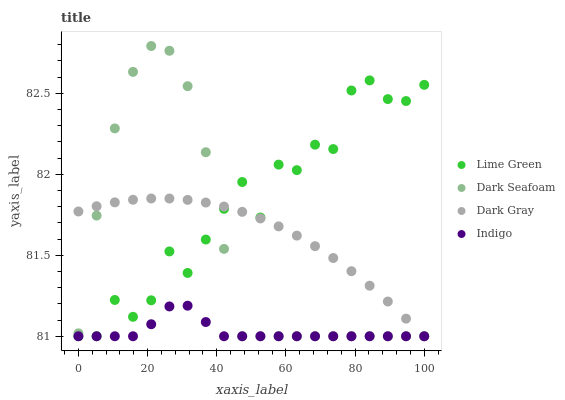Does Indigo have the minimum area under the curve?
Answer yes or no. Yes. Does Lime Green have the maximum area under the curve?
Answer yes or no. Yes. Does Dark Seafoam have the minimum area under the curve?
Answer yes or no. No. Does Dark Seafoam have the maximum area under the curve?
Answer yes or no. No. Is Dark Gray the smoothest?
Answer yes or no. Yes. Is Lime Green the roughest?
Answer yes or no. Yes. Is Indigo the smoothest?
Answer yes or no. No. Is Indigo the roughest?
Answer yes or no. No. Does Dark Gray have the lowest value?
Answer yes or no. Yes. Does Dark Seafoam have the highest value?
Answer yes or no. Yes. Does Indigo have the highest value?
Answer yes or no. No. Does Dark Gray intersect Dark Seafoam?
Answer yes or no. Yes. Is Dark Gray less than Dark Seafoam?
Answer yes or no. No. Is Dark Gray greater than Dark Seafoam?
Answer yes or no. No. 